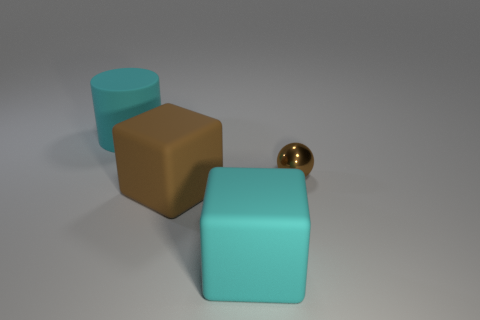Add 4 big gray rubber blocks. How many objects exist? 8 Subtract all cylinders. How many objects are left? 3 Subtract all large cyan matte things. Subtract all small brown balls. How many objects are left? 1 Add 1 large brown matte things. How many large brown matte things are left? 2 Add 4 brown matte things. How many brown matte things exist? 5 Subtract 0 red cylinders. How many objects are left? 4 